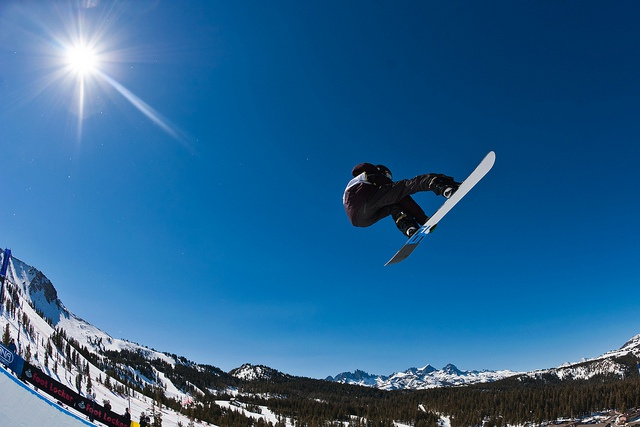Describe the objects in this image and their specific colors. I can see people in blue, black, gray, and darkgray tones and snowboard in blue, darkgray, black, and lightgray tones in this image. 